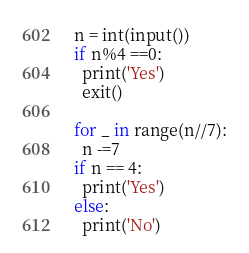Convert code to text. <code><loc_0><loc_0><loc_500><loc_500><_Python_>n = int(input())
if n%4 ==0:
  print('Yes')
  exit()

for _ in range(n//7):
  n -=7
if n == 4:
  print('Yes')
else:
  print('No')</code> 